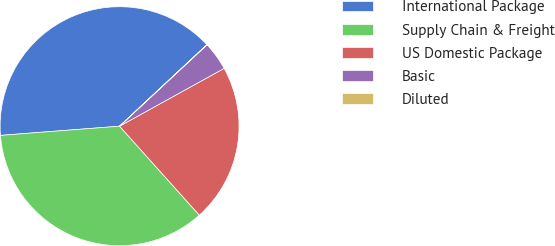Convert chart. <chart><loc_0><loc_0><loc_500><loc_500><pie_chart><fcel>International Package<fcel>Supply Chain & Freight<fcel>US Domestic Package<fcel>Basic<fcel>Diluted<nl><fcel>39.28%<fcel>35.41%<fcel>21.41%<fcel>3.89%<fcel>0.02%<nl></chart> 